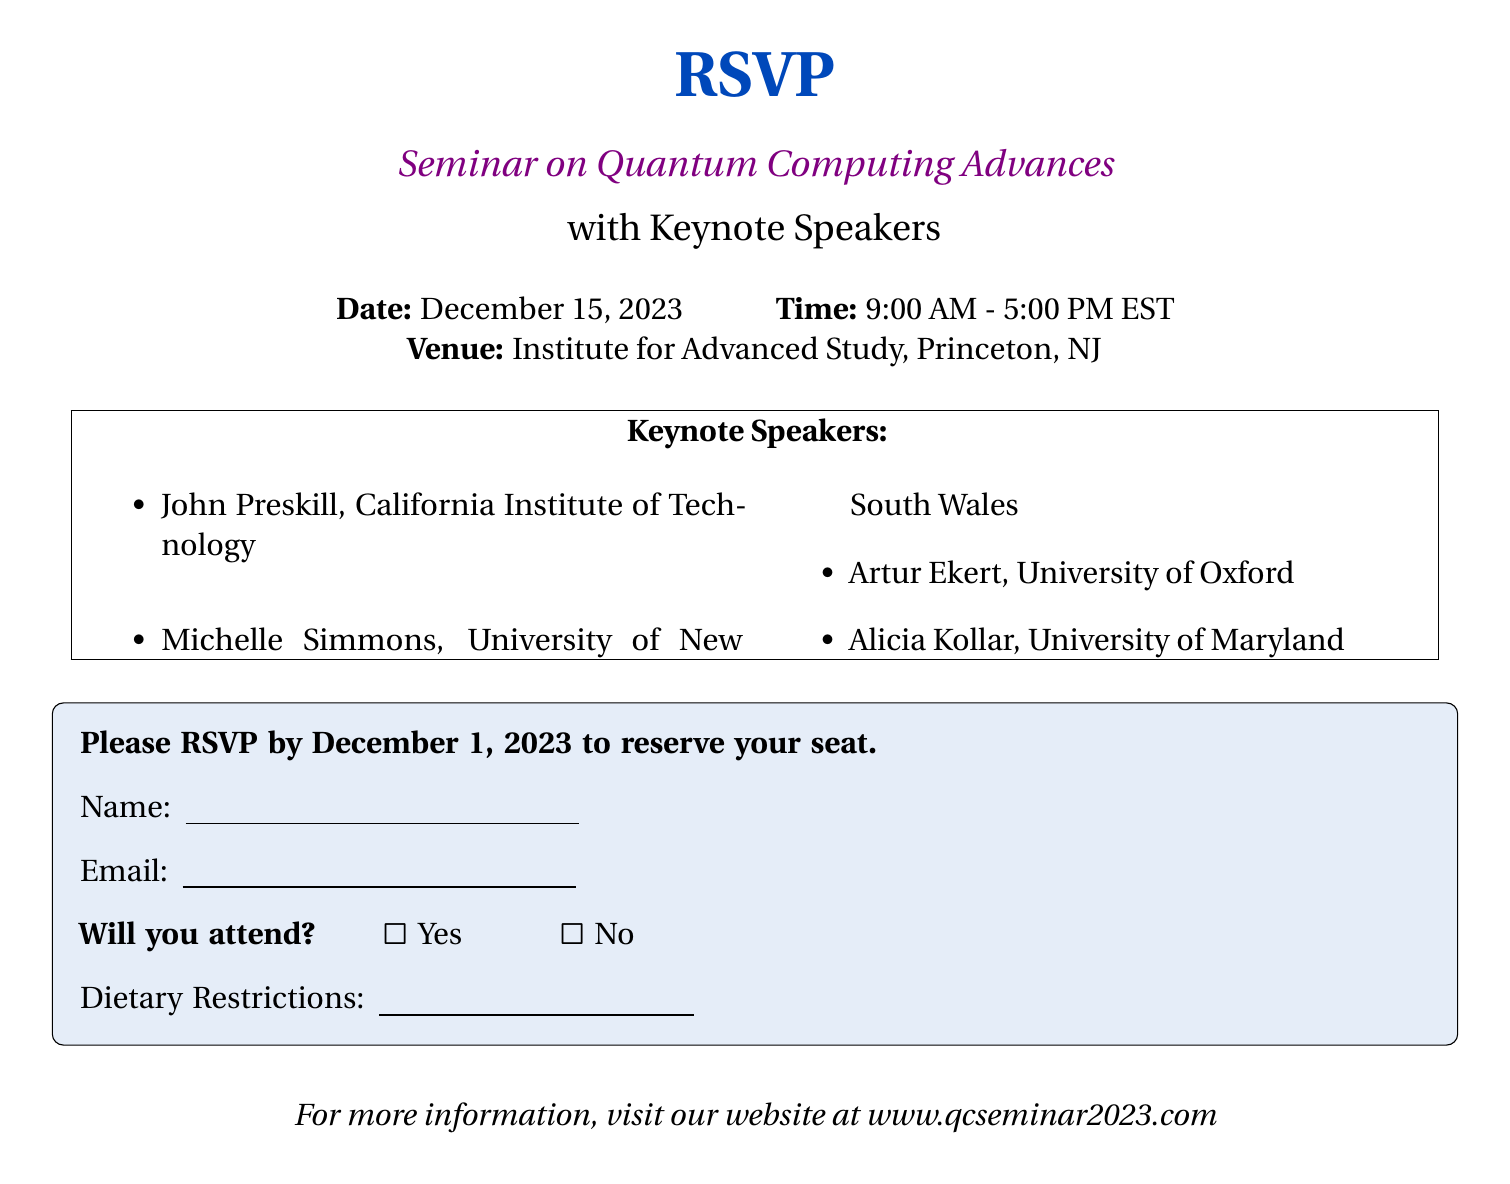What is the date of the seminar? The date of the seminar is explicitly mentioned in the document.
Answer: December 15, 2023 What time does the seminar start? The beginning time of the seminar is provided in the document.
Answer: 9:00 AM Where is the seminar venue? The document specifies the location of the seminar.
Answer: Institute for Advanced Study, Princeton, NJ Who is one of the keynote speakers? The names of the keynote speakers are listed in the document.
Answer: John Preskill What is the RSVP deadline? The last date to RSVP is stated in the document.
Answer: December 1, 2023 How many keynote speakers are mentioned? The document lists the number of keynote speakers in the itemized list.
Answer: Four Is there a section for dietary restrictions? The document includes a space for dietary restrictions, confirming this aspect.
Answer: Yes What is the seminar's end time? The document specifies the ending time of the seminar.
Answer: 5:00 PM What website can provide more information? The document includes a website for further seminar information.
Answer: www.qcseminar2023.com 